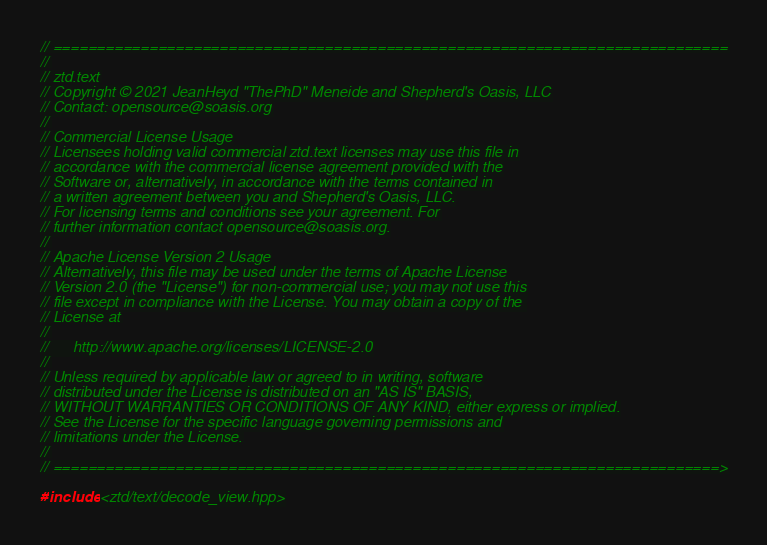Convert code to text. <code><loc_0><loc_0><loc_500><loc_500><_C++_>// =============================================================================
//
// ztd.text
// Copyright © 2021 JeanHeyd "ThePhD" Meneide and Shepherd's Oasis, LLC
// Contact: opensource@soasis.org
//
// Commercial License Usage
// Licensees holding valid commercial ztd.text licenses may use this file in
// accordance with the commercial license agreement provided with the
// Software or, alternatively, in accordance with the terms contained in
// a written agreement between you and Shepherd's Oasis, LLC.
// For licensing terms and conditions see your agreement. For
// further information contact opensource@soasis.org.
//
// Apache License Version 2 Usage
// Alternatively, this file may be used under the terms of Apache License
// Version 2.0 (the "License") for non-commercial use; you may not use this
// file except in compliance with the License. You may obtain a copy of the 
// License at
//
//		http://www.apache.org/licenses/LICENSE-2.0
//
// Unless required by applicable law or agreed to in writing, software
// distributed under the License is distributed on an "AS IS" BASIS,
// WITHOUT WARRANTIES OR CONDITIONS OF ANY KIND, either express or implied.
// See the License for the specific language governing permissions and
// limitations under the License.
//
// ============================================================================>

#include <ztd/text/decode_view.hpp>
</code> 